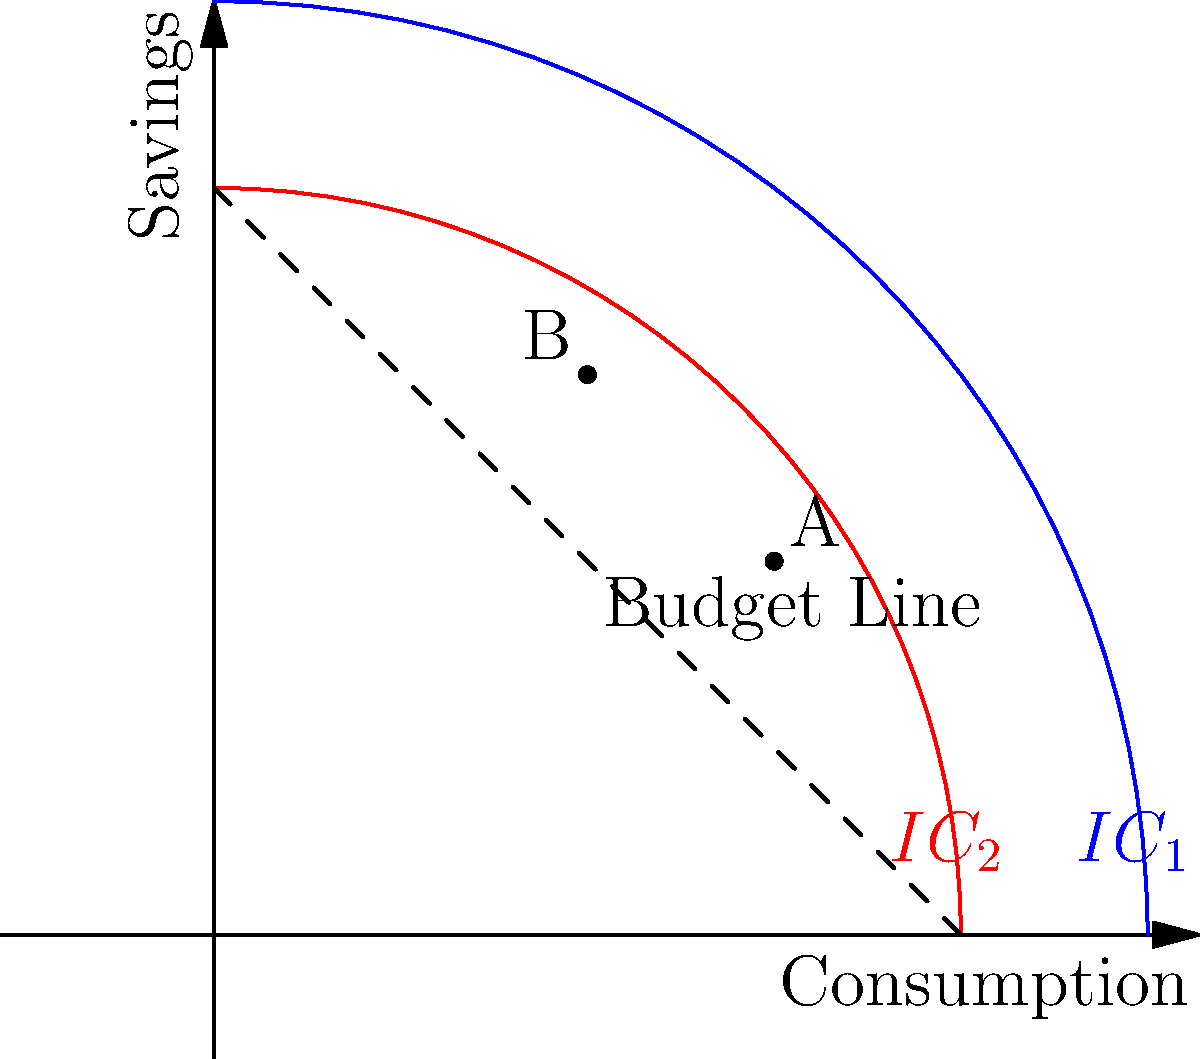Consider the indifference curve diagram above, which shows two indifference curves ($IC_1$ and $IC_2$) and a budget line. Point A represents the current consumption-savings combination. If the individual decides to move from point A to point B, what can we conclude about their preferences and the trade-off between consumption and savings? To answer this question, let's analyze the diagram step-by-step:

1. Indifference curves: 
   - $IC_1$ (blue) and $IC_2$ (red) represent different levels of utility.
   - $IC_2$ is closer to the origin, indicating a lower level of utility than $IC_1$.

2. Budget line:
   - The dashed line represents the budget constraint.
   - Both points A and B lie on this line, indicating they are feasible choices given the individual's income.

3. Movement from A to B:
   - Point A is on $IC_1$, while point B is on $IC_2$.
   - Moving from A to B involves:
     a) Decreasing consumption (moving left on the x-axis)
     b) Increasing savings (moving up on the y-axis)

4. Utility change:
   - Since B is on a lower indifference curve ($IC_2$), this move results in a decrease in utility.

5. Trade-off analysis:
   - The individual is sacrificing some current consumption for higher savings.
   - This decision suggests a preference for future consumption over present consumption.

6. Economic interpretation:
   - This could indicate an increased focus on long-term financial goals, such as retirement planning.
   - The individual is willing to accept a lower current utility for potentially higher future utility.

In conclusion, moving from A to B demonstrates a trade-off where the individual chooses to increase savings at the expense of current consumption and utility, suggesting a stronger preference for future financial security.
Answer: Increased preference for savings over current consumption, accepting lower present utility for potential future benefits. 